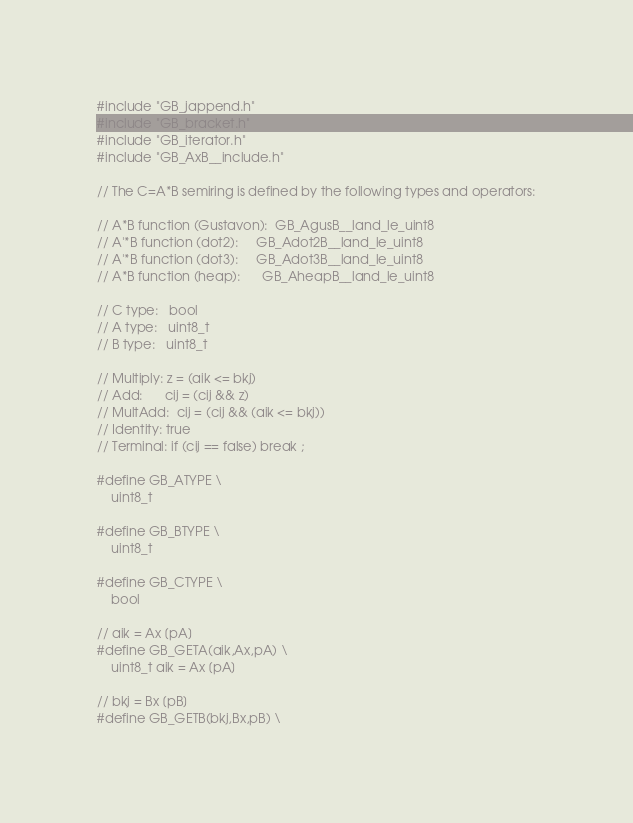Convert code to text. <code><loc_0><loc_0><loc_500><loc_500><_C_>#include "GB_jappend.h"
#include "GB_bracket.h"
#include "GB_iterator.h"
#include "GB_AxB__include.h"

// The C=A*B semiring is defined by the following types and operators:

// A*B function (Gustavon):  GB_AgusB__land_le_uint8
// A'*B function (dot2):     GB_Adot2B__land_le_uint8
// A'*B function (dot3):     GB_Adot3B__land_le_uint8
// A*B function (heap):      GB_AheapB__land_le_uint8

// C type:   bool
// A type:   uint8_t
// B type:   uint8_t

// Multiply: z = (aik <= bkj)
// Add:      cij = (cij && z)
// MultAdd:  cij = (cij && (aik <= bkj))
// Identity: true
// Terminal: if (cij == false) break ;

#define GB_ATYPE \
    uint8_t

#define GB_BTYPE \
    uint8_t

#define GB_CTYPE \
    bool

// aik = Ax [pA]
#define GB_GETA(aik,Ax,pA) \
    uint8_t aik = Ax [pA]

// bkj = Bx [pB]
#define GB_GETB(bkj,Bx,pB) \</code> 